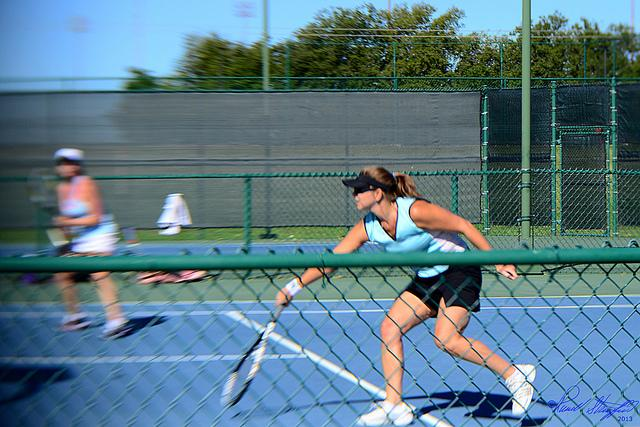What surface are they playing on?

Choices:
A) grass
B) clay
C) indoor hard
D) outdoor hard outdoor hard 